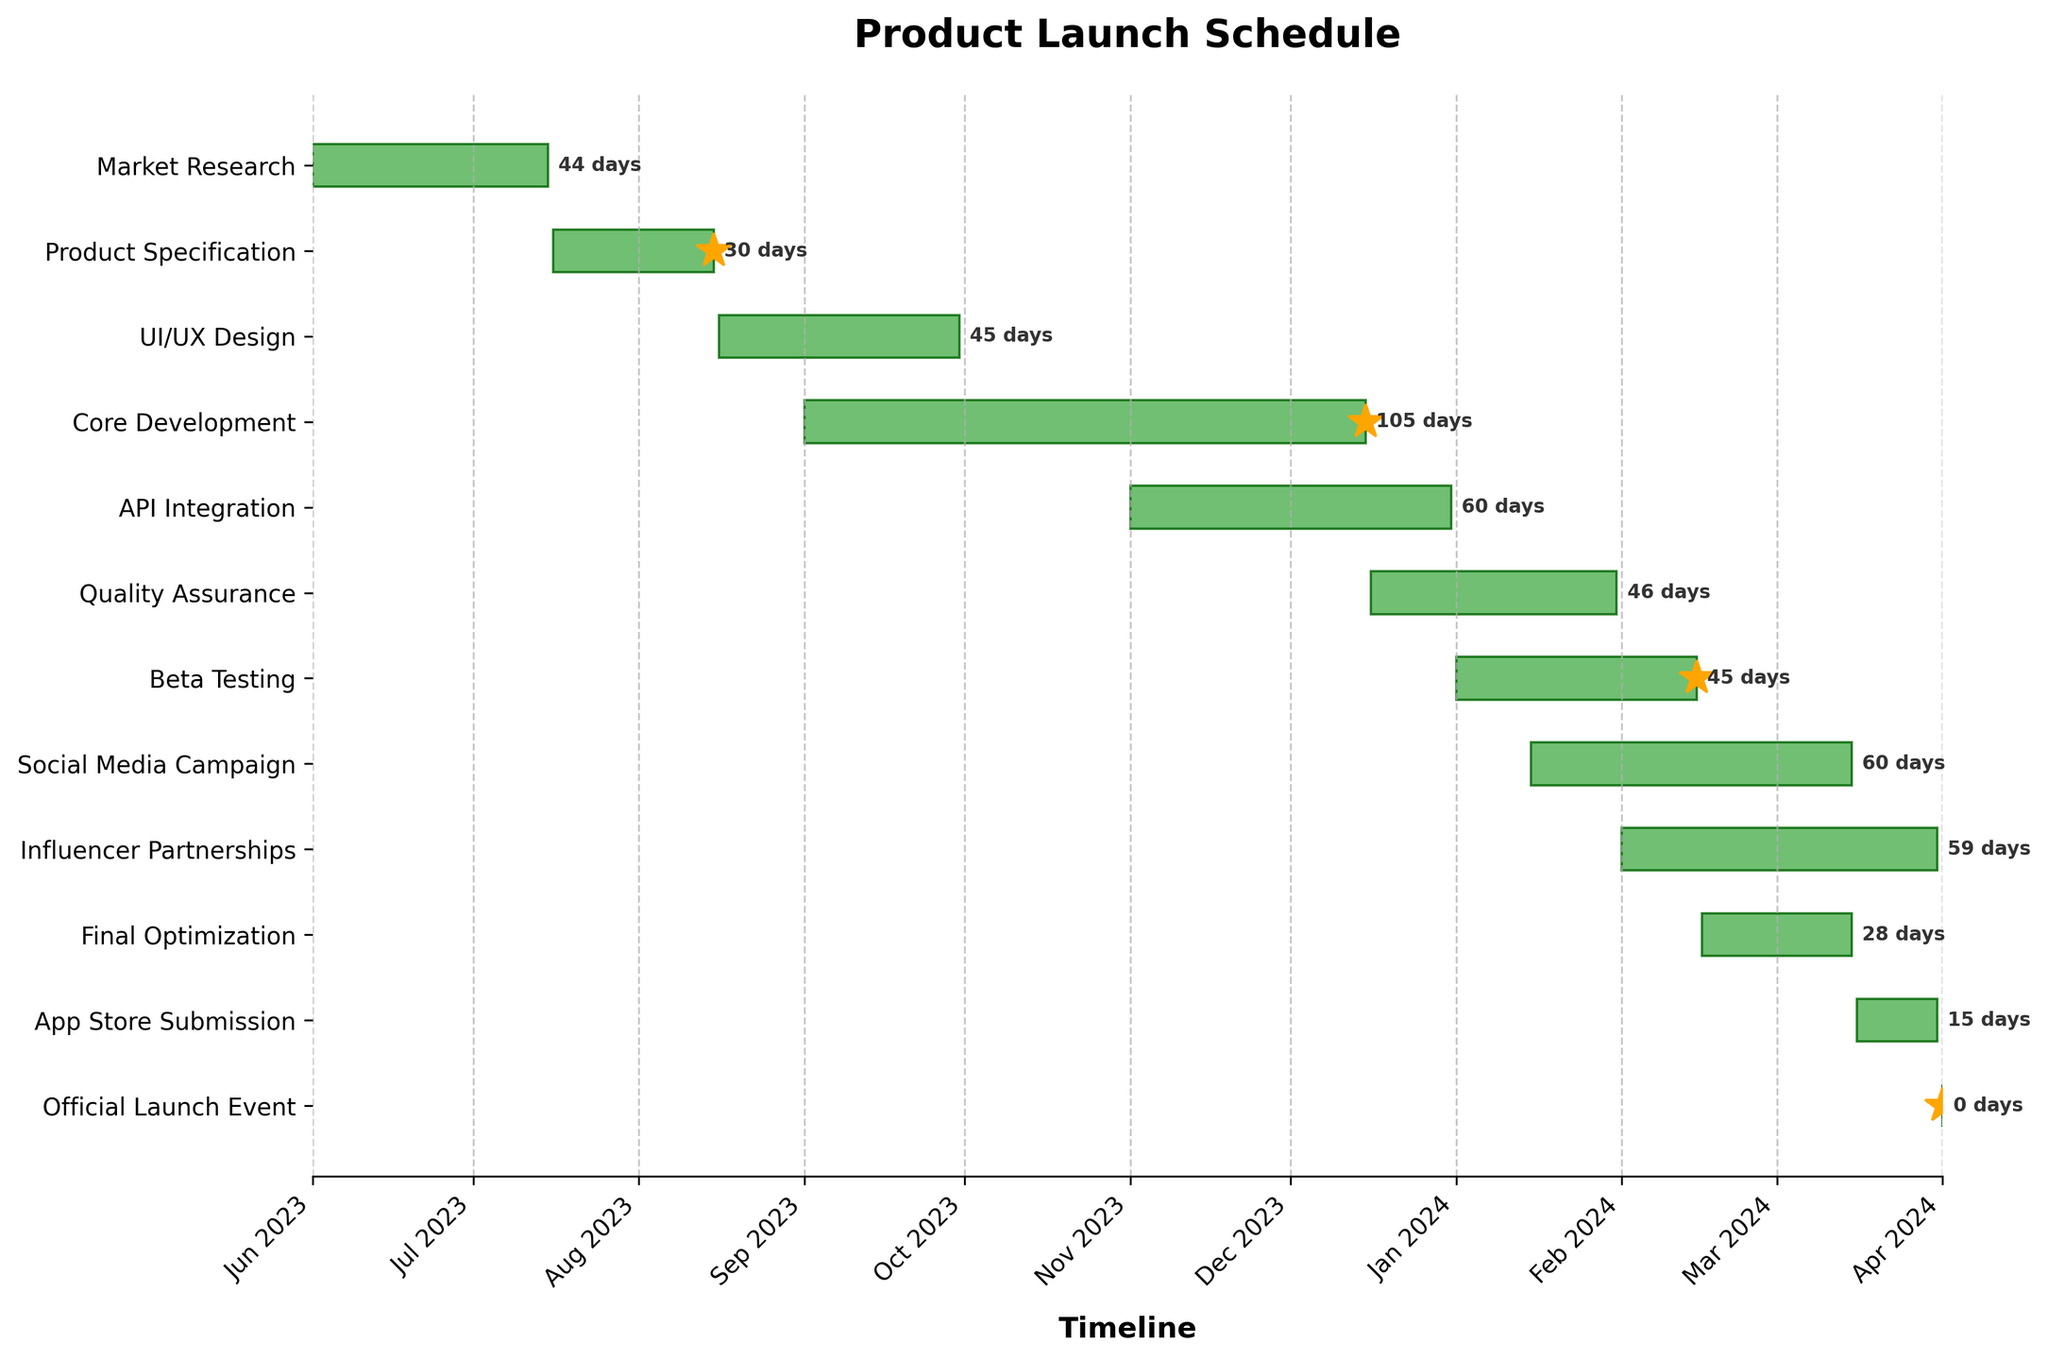What is the title of the chart? The title of the chart is typically found at the top and provides an overview of what the chart is about. In this case, the title is displayed prominently and should be easy to identify.
Answer: Product Launch Schedule How many tasks are there in total? To find the total number of tasks, count each task listed on the y-axis. These tasks represent various stages of the product launch schedule.
Answer: 11 Which task has the shortest duration? The duration of each task can be seen by either looking at the length of the bars or noting the days listed next to each bar. The shortest duration is the task with the fewest days.
Answer: Official Launch Event What tasks are indicated as milestones? Milestones in the chart are typically marked with special symbols or markers. Here, look for any tasks with a distinct marker such as a star.
Answer: Product Specification, Core Development, Beta Testing, Official Launch Event Which two tasks have overlapping timelines in February 2024? Check for bars that start within the timeframe of February 2024. Look for any tasks that have bars that span across or overlap in this time frame.
Answer: Beta Testing and Influencer Partnerships What is the duration of the Beta Testing phase? To find this, look at the start and end dates of Beta Testing or check the duration written next to its bar.
Answer: 46 days When does the Core Development phase end? Identify the bar for Core Development and check the end date indicated either by the length of the bar or the date listed next to it.
Answer: December 15, 2023 Which task starts immediately after UI/UX Design is completed? Notice the end date of the UI/UX Design bar and see which task's start date follows it directly.
Answer: Core Development How long is the Social Media Campaign relative to the whole product launch timeline? First, determine the duration of the Social Media Campaign. Then, measure total time from the start of the first task to the end of the last task, and compare the duration of Social Media Campaign to this total timeline.
Answer: Social Media Campaign is 61 days out of a total spanning from June 2023 to April 1, 2024 List any tasks that start within January 2024. Look at the bars that begin in January 2024 by checking their start dates.
Answer: Beta Testing, Social Media Campaign 